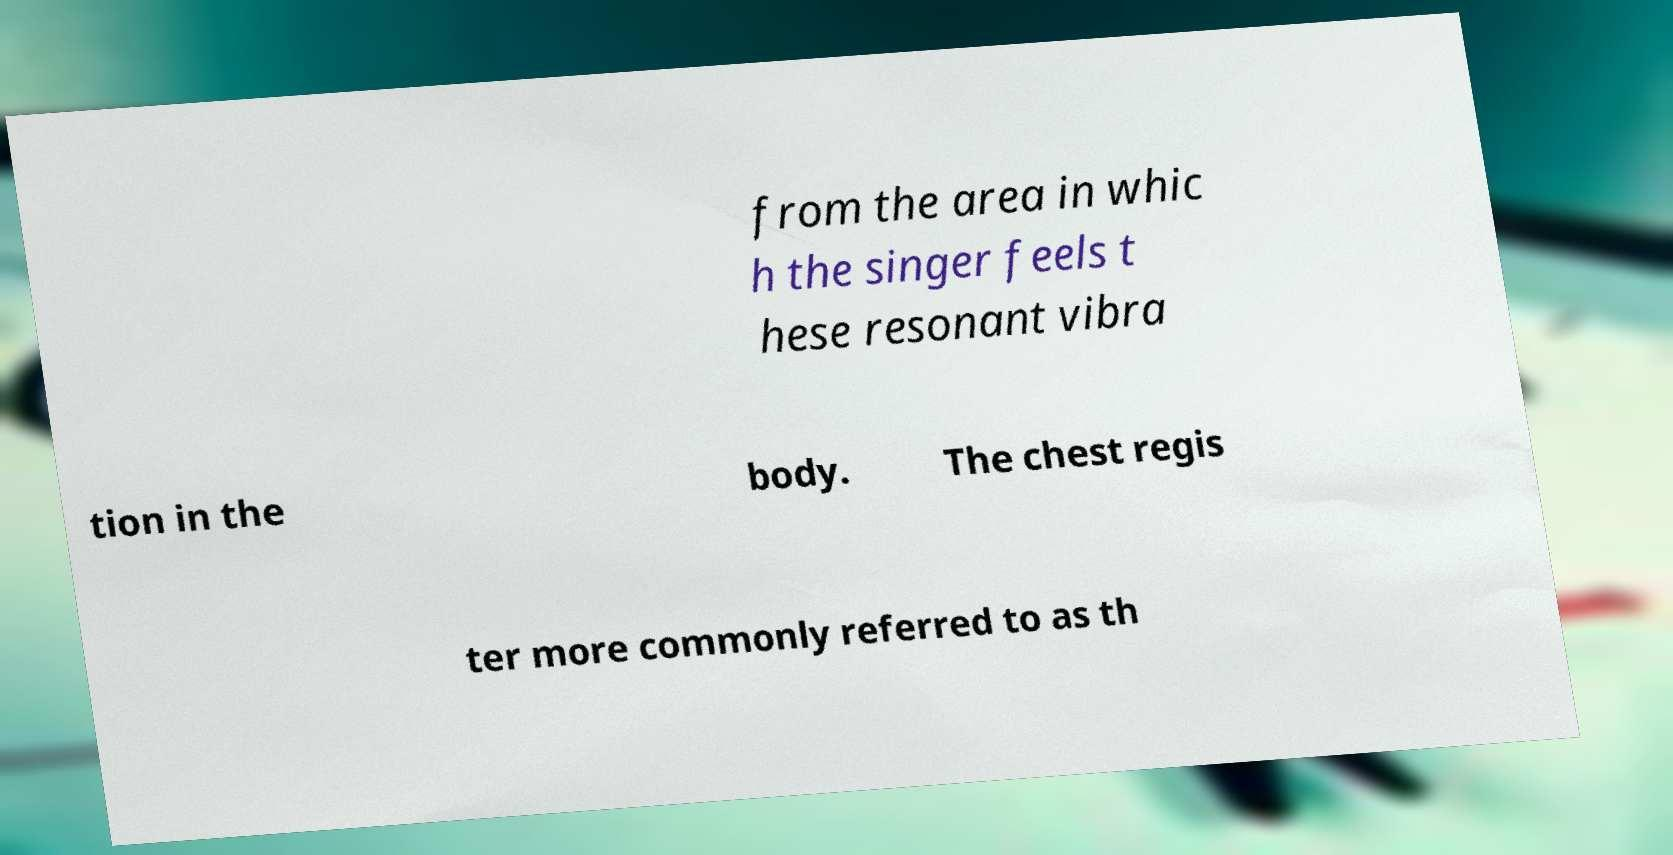What messages or text are displayed in this image? I need them in a readable, typed format. from the area in whic h the singer feels t hese resonant vibra tion in the body. The chest regis ter more commonly referred to as th 